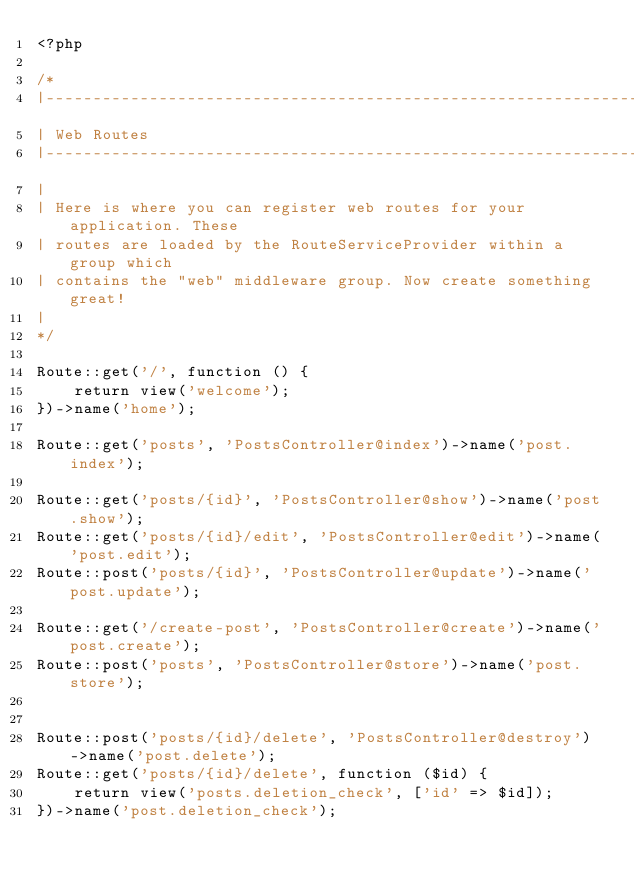<code> <loc_0><loc_0><loc_500><loc_500><_PHP_><?php

/*
|--------------------------------------------------------------------------
| Web Routes
|--------------------------------------------------------------------------
|
| Here is where you can register web routes for your application. These
| routes are loaded by the RouteServiceProvider within a group which
| contains the "web" middleware group. Now create something great!
|
*/

Route::get('/', function () {
    return view('welcome');
})->name('home');

Route::get('posts', 'PostsController@index')->name('post.index');

Route::get('posts/{id}', 'PostsController@show')->name('post.show');
Route::get('posts/{id}/edit', 'PostsController@edit')->name('post.edit');
Route::post('posts/{id}', 'PostsController@update')->name('post.update');

Route::get('/create-post', 'PostsController@create')->name('post.create');
Route::post('posts', 'PostsController@store')->name('post.store');


Route::post('posts/{id}/delete', 'PostsController@destroy')->name('post.delete');
Route::get('posts/{id}/delete', function ($id) {
    return view('posts.deletion_check', ['id' => $id]);
})->name('post.deletion_check');
</code> 